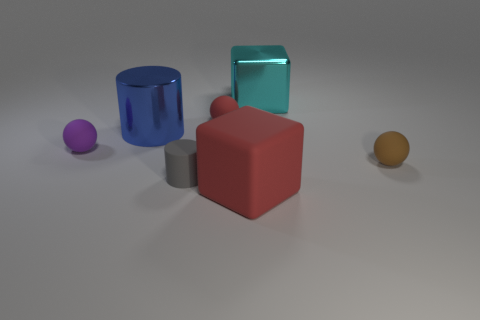Add 1 large matte blocks. How many objects exist? 8 Subtract all spheres. How many objects are left? 4 Add 7 large cyan metal things. How many large cyan metal things are left? 8 Add 2 big metallic cylinders. How many big metallic cylinders exist? 3 Subtract 0 red cylinders. How many objects are left? 7 Subtract all large blue cylinders. Subtract all big blue cylinders. How many objects are left? 5 